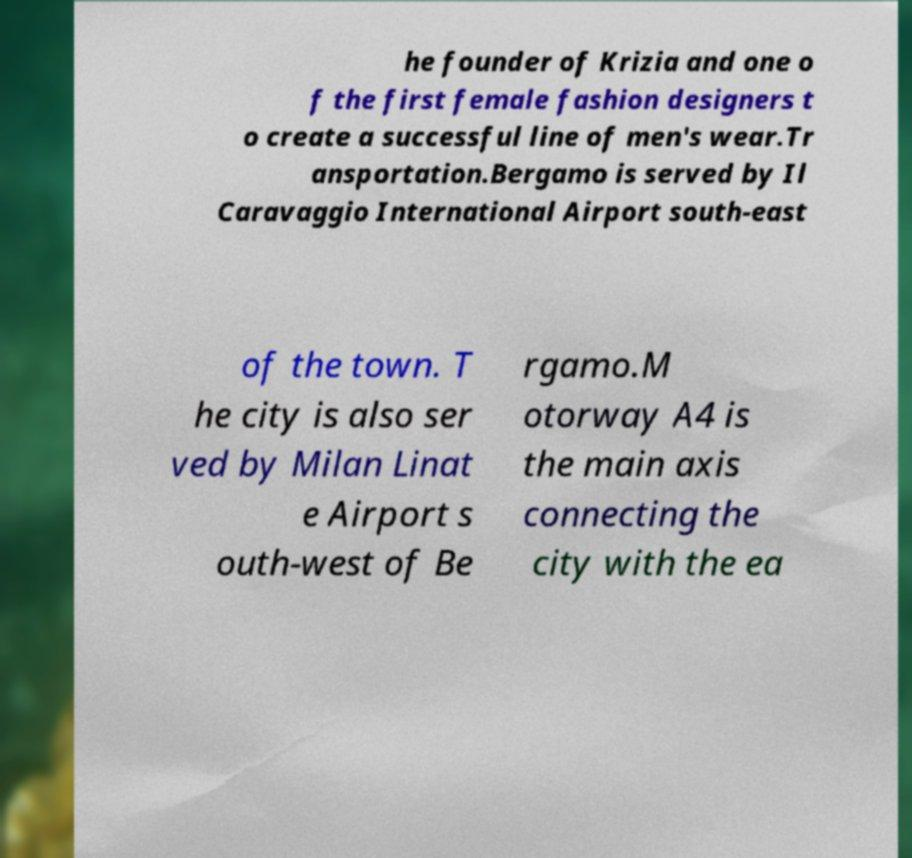Can you accurately transcribe the text from the provided image for me? he founder of Krizia and one o f the first female fashion designers t o create a successful line of men's wear.Tr ansportation.Bergamo is served by Il Caravaggio International Airport south-east of the town. T he city is also ser ved by Milan Linat e Airport s outh-west of Be rgamo.M otorway A4 is the main axis connecting the city with the ea 